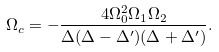<formula> <loc_0><loc_0><loc_500><loc_500>\Omega _ { c } = - \frac { 4 \Omega _ { 0 } ^ { 2 } \Omega _ { 1 } \Omega _ { 2 } } { \Delta ( \Delta - \Delta ^ { \prime } ) ( \Delta + \Delta ^ { \prime } ) } .</formula> 